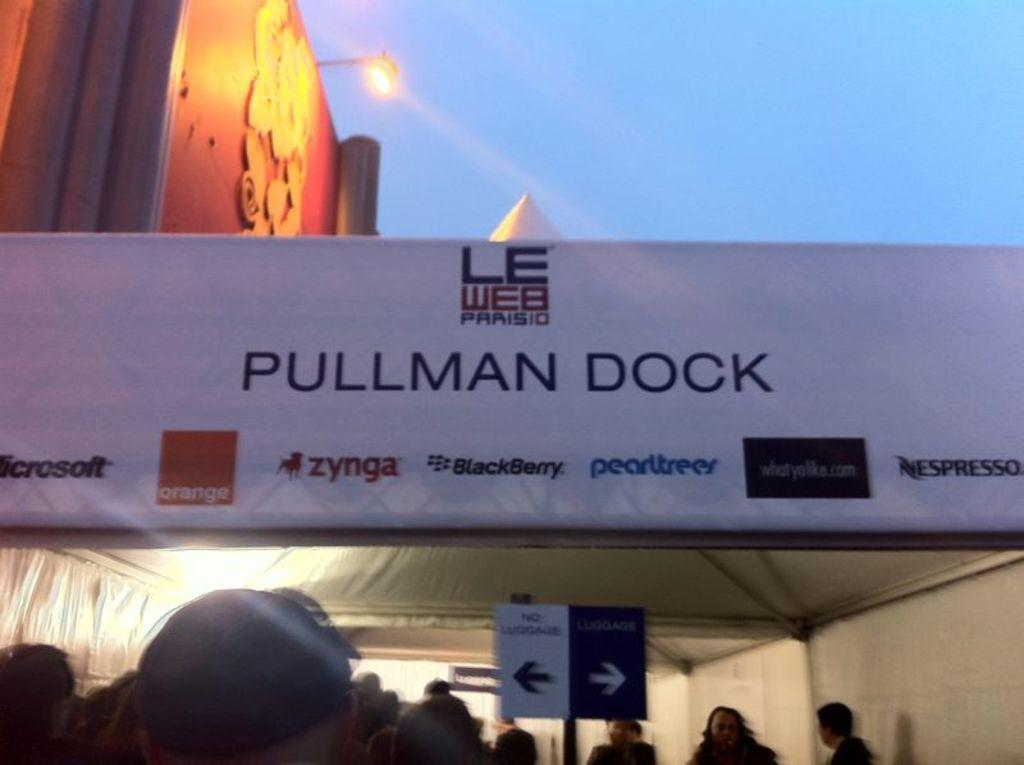<image>
Give a short and clear explanation of the subsequent image. A white canvas tent is labeled "Pullman Dock." 